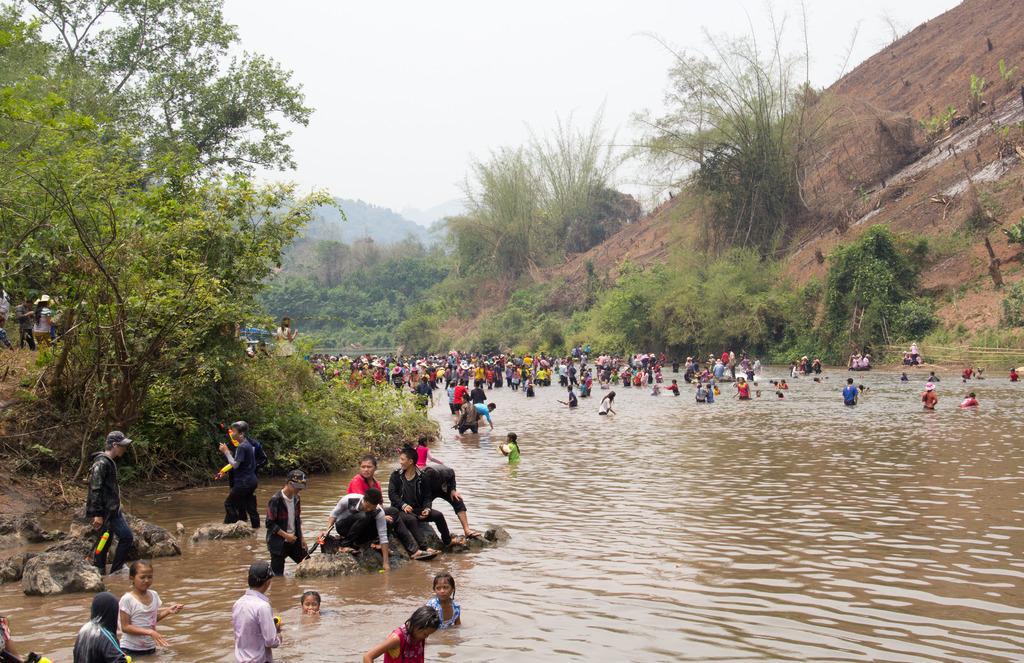In one or two sentences, can you explain what this image depicts? In this image we can see a group of people in the water body. On the bottom of the image we can see a wooden fence and some people sitting on stones. On the backside we can see a group of trees and some people on the hills and the sky which looks cloudy. 